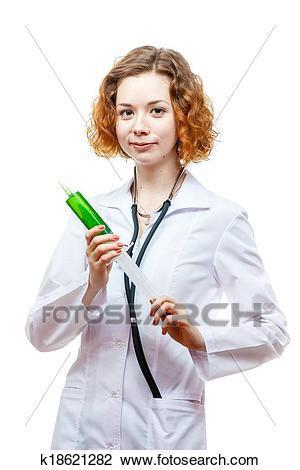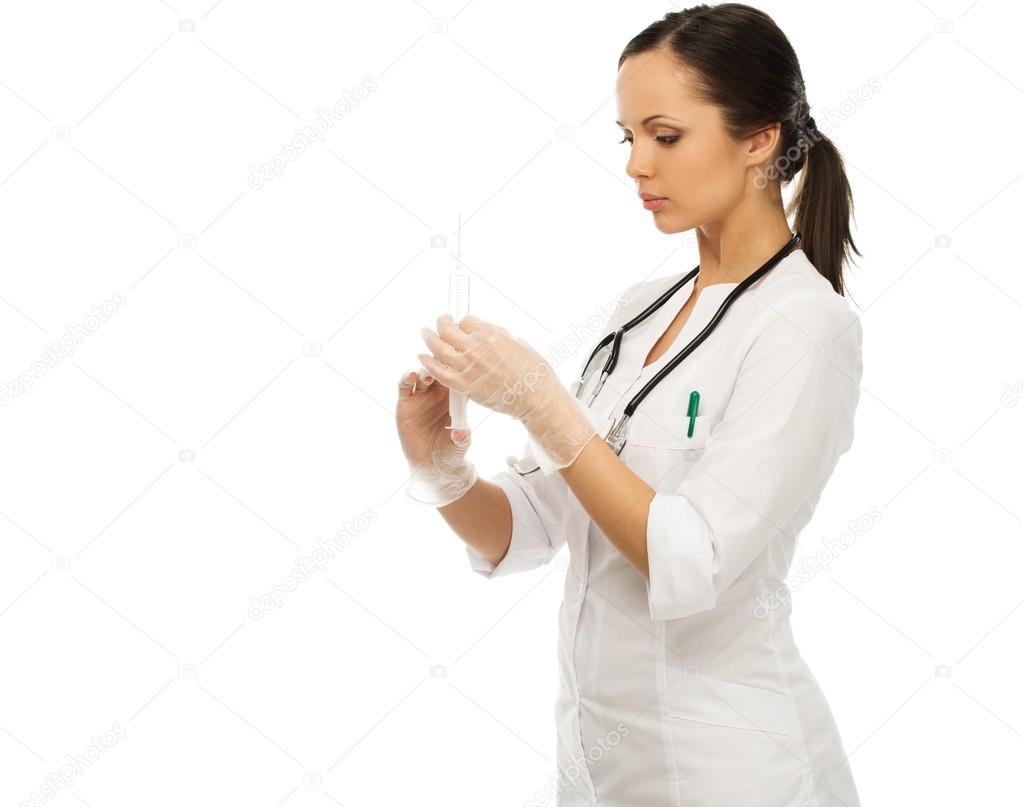The first image is the image on the left, the second image is the image on the right. For the images shown, is this caption "There are two women holding needles." true? Answer yes or no. Yes. The first image is the image on the left, the second image is the image on the right. Examine the images to the left and right. Is the description "Two women are holding syringes." accurate? Answer yes or no. Yes. 